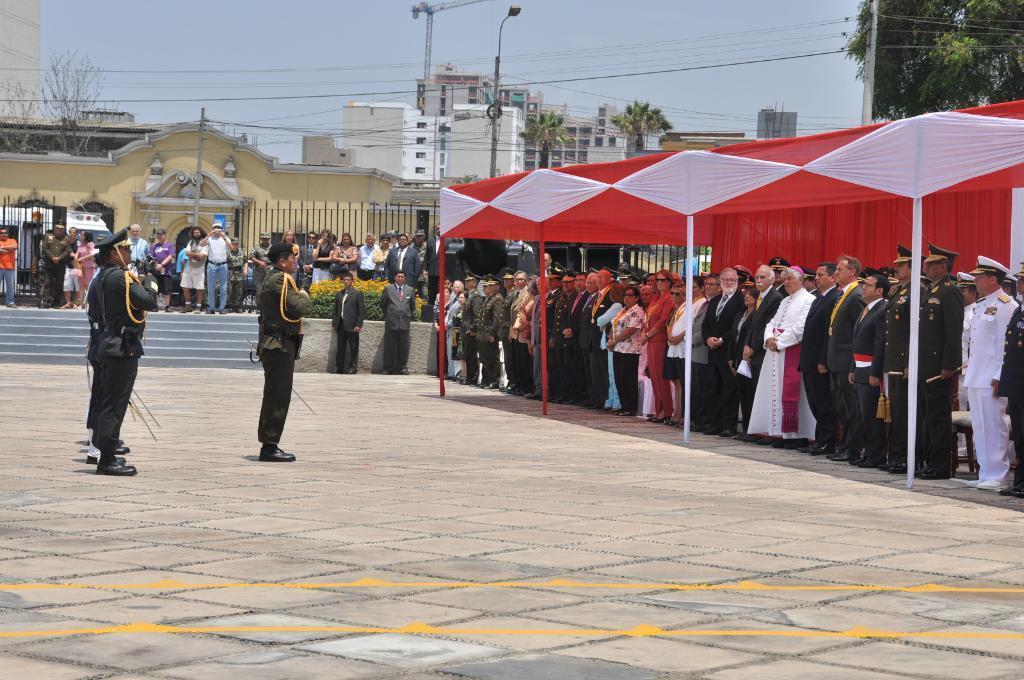Please provide a concise description of this image. In this image few persons are standing on the floor. They are wearing uniform and caps. Few persons are standing under the tent. Few persons are standing behind the stairs. There are two persons wearing suit. Behind them there are few plants. Behind the fence there are few trees, buildings, street light and few poles connected with wires. Top of image there is sky. 